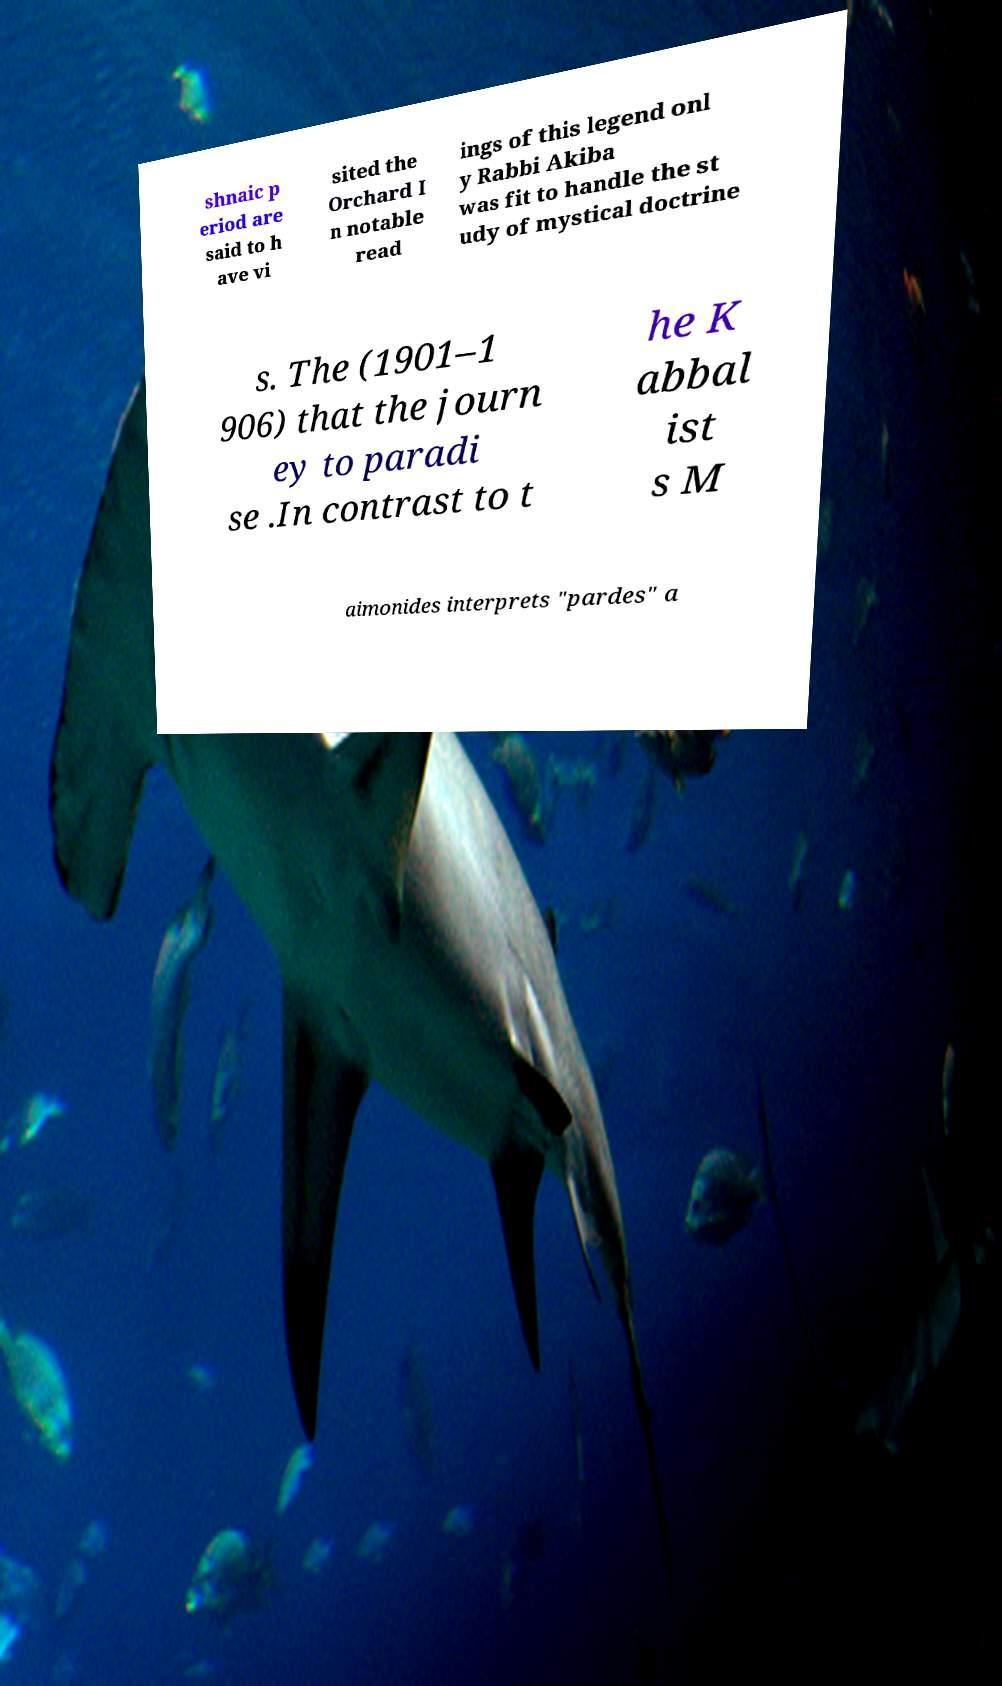Can you read and provide the text displayed in the image?This photo seems to have some interesting text. Can you extract and type it out for me? shnaic p eriod are said to h ave vi sited the Orchard I n notable read ings of this legend onl y Rabbi Akiba was fit to handle the st udy of mystical doctrine s. The (1901–1 906) that the journ ey to paradi se .In contrast to t he K abbal ist s M aimonides interprets "pardes" a 